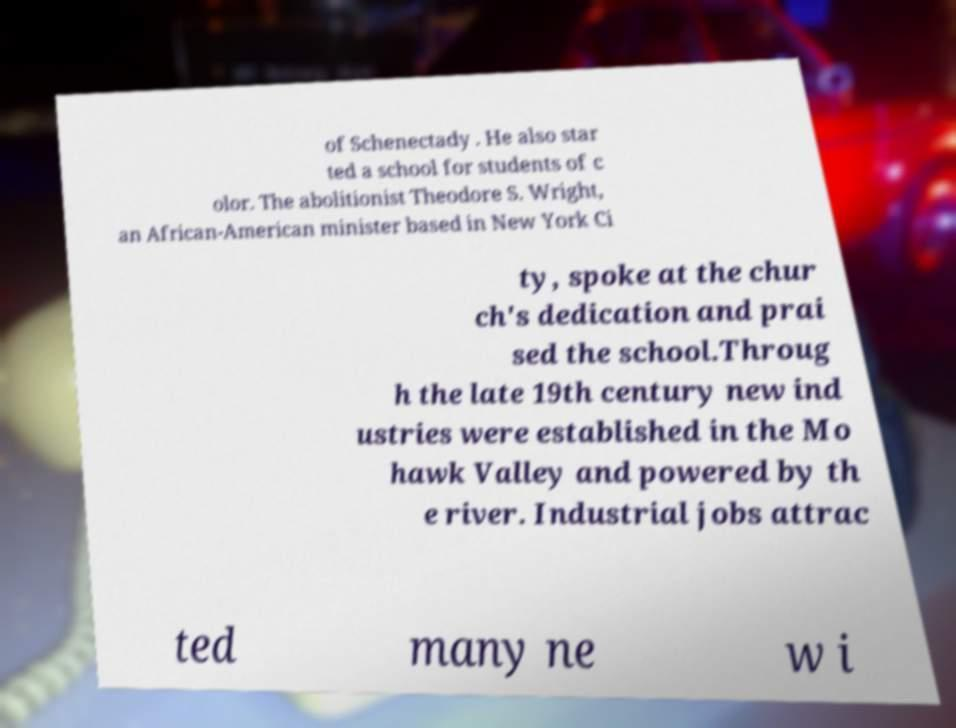Could you extract and type out the text from this image? of Schenectady . He also star ted a school for students of c olor. The abolitionist Theodore S. Wright, an African-American minister based in New York Ci ty, spoke at the chur ch's dedication and prai sed the school.Throug h the late 19th century new ind ustries were established in the Mo hawk Valley and powered by th e river. Industrial jobs attrac ted many ne w i 